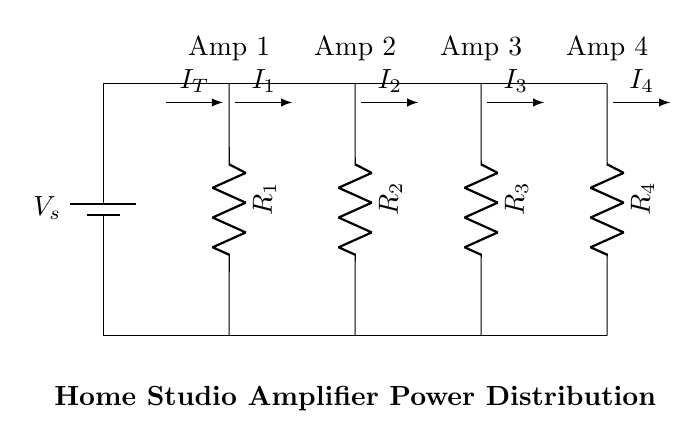What is the power source in this circuit? The power source is a battery, labeled as Vs. It is located at the left side of the circuit, providing the necessary voltage for the parallel branches.
Answer: battery How many amplifiers are connected in this circuit? There are four amplifiers, as indicated by the labels above each branch (Amp 1, Amp 2, Amp 3, Amp 4) connected to the power distribution system.
Answer: four What is the total current entering the parallel circuit? The total current is denoted by IT in the circuit diagram, which is the current flowing from the battery before splitting into the branches.
Answer: IT Which resistor corresponds to Amp 2? The resistor corresponding to Amp 2 is labeled as R2, which is the second resistor in the parallel arrangement.
Answer: R2 If both R1 and R2 have the same resistance, which amplifier receives more current? Since R1 and R2 have the same resistance, the current dividers will share the total current equally. Therefore, both amplifiers AMP1 and AMP2 will receive equal current, despite being in parallel. For further understanding, the total current splits between parallel branches inversely proportional to their resistances.
Answer: Amp 1 and Amp 2 What happens to the total current when a resistor is removed from the circuit? When a resistor is removed from the parallel circuit, the total current will increase as the overall resistance of the circuit decreases. This is because fewer branches for current to flow through will change the equivalent resistance which allows more current to flow from the power source, Vod.
Answer: increases What is the relationship between the voltage across each resistor in the parallel circuit? The voltage across each resistor in a parallel circuit remains constant and equals the source voltage, Vs. This is due to all resistors being connected directly across the same two points, leading to the same potential difference across them.
Answer: Vs 